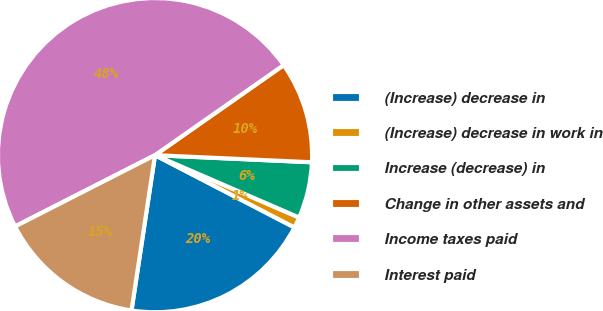Convert chart. <chart><loc_0><loc_0><loc_500><loc_500><pie_chart><fcel>(Increase) decrease in<fcel>(Increase) decrease in work in<fcel>Increase (decrease) in<fcel>Change in other assets and<fcel>Income taxes paid<fcel>Interest paid<nl><fcel>19.78%<fcel>1.11%<fcel>5.78%<fcel>10.44%<fcel>47.78%<fcel>15.11%<nl></chart> 